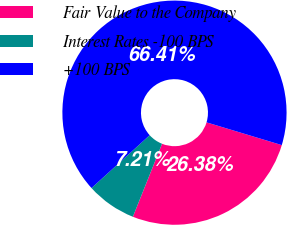<chart> <loc_0><loc_0><loc_500><loc_500><pie_chart><fcel>Fair Value to the Company<fcel>Interest Rates -100 BPS<fcel>+100 BPS<nl><fcel>26.38%<fcel>7.21%<fcel>66.41%<nl></chart> 